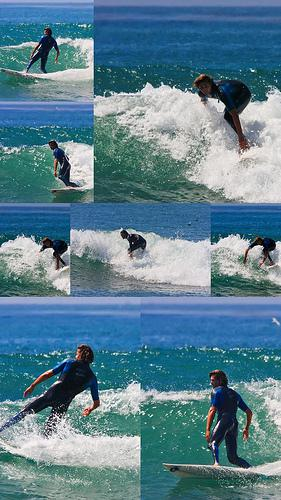Question: what is the surfer on?
Choices:
A. Boogieboard.
B. Surfboard.
C. Sand.
D. Waveboard.
Answer with the letter. Answer: B Question: where is this scene?
Choices:
A. Water.
B. Beach.
C. Fishing pier.
D. Boat.
Answer with the letter. Answer: A Question: how many pictures?
Choices:
A. 12.
B. 8.
C. 13.
D. 5.
Answer with the letter. Answer: B Question: who is in the photo?
Choices:
A. Surfer.
B. Boater.
C. Life Guard.
D. Swimmers.
Answer with the letter. Answer: A Question: who is surfing?
Choices:
A. Woman.
B. Man.
C. Girl.
D. Boy.
Answer with the letter. Answer: B 